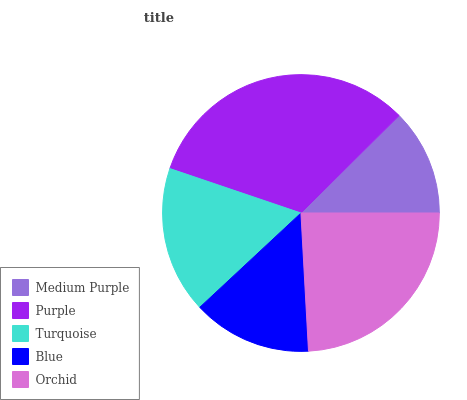Is Medium Purple the minimum?
Answer yes or no. Yes. Is Purple the maximum?
Answer yes or no. Yes. Is Turquoise the minimum?
Answer yes or no. No. Is Turquoise the maximum?
Answer yes or no. No. Is Purple greater than Turquoise?
Answer yes or no. Yes. Is Turquoise less than Purple?
Answer yes or no. Yes. Is Turquoise greater than Purple?
Answer yes or no. No. Is Purple less than Turquoise?
Answer yes or no. No. Is Turquoise the high median?
Answer yes or no. Yes. Is Turquoise the low median?
Answer yes or no. Yes. Is Purple the high median?
Answer yes or no. No. Is Orchid the low median?
Answer yes or no. No. 